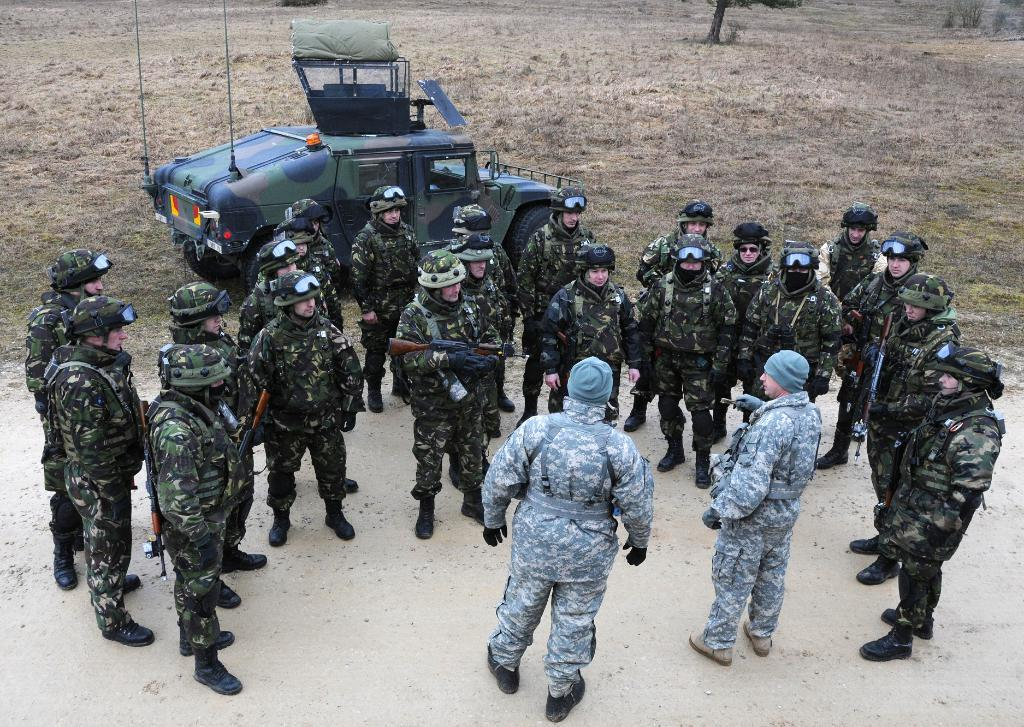How many men are in the image? There are multiple men in the image. What are the men wearing? The men are wearing army uniforms. What are the men holding in their hands? The men are holding guns in their hands. What can be seen in the image besides the men? There is a vehicle visible in the image, as well as at least one tree. What type of collar is the daughter wearing in the image? There is no daughter present in the image, so there is no collar to describe. 